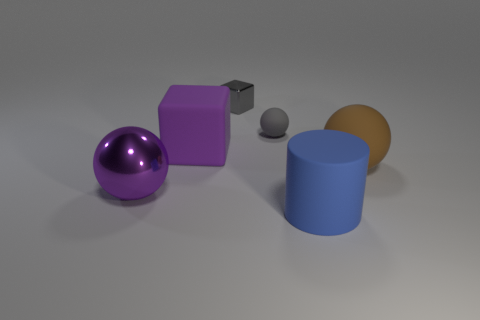Is the number of rubber cylinders that are behind the tiny ball the same as the number of large shiny objects?
Ensure brevity in your answer.  No. What is the color of the metal object that is the same size as the blue matte thing?
Offer a terse response. Purple. Are there any tiny brown metal objects that have the same shape as the blue thing?
Your answer should be compact. No. The object in front of the big purple metal thing left of the large thing to the right of the blue matte cylinder is made of what material?
Make the answer very short. Rubber. What number of other objects are there of the same size as the brown matte ball?
Give a very brief answer. 3. The tiny sphere is what color?
Keep it short and to the point. Gray. What number of metallic objects are either brown objects or tiny gray cylinders?
Offer a terse response. 0. Is there anything else that has the same material as the large brown sphere?
Provide a succinct answer. Yes. What size is the sphere left of the block that is to the left of the tiny gray object that is behind the tiny gray ball?
Provide a succinct answer. Large. There is a object that is in front of the brown matte thing and left of the big blue rubber cylinder; what size is it?
Make the answer very short. Large. 